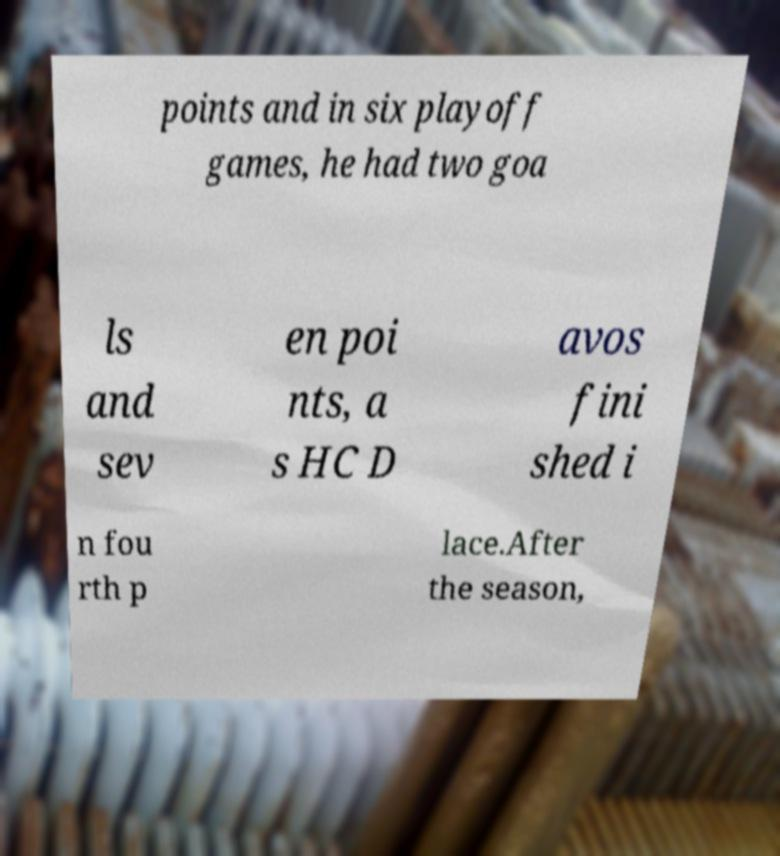I need the written content from this picture converted into text. Can you do that? points and in six playoff games, he had two goa ls and sev en poi nts, a s HC D avos fini shed i n fou rth p lace.After the season, 